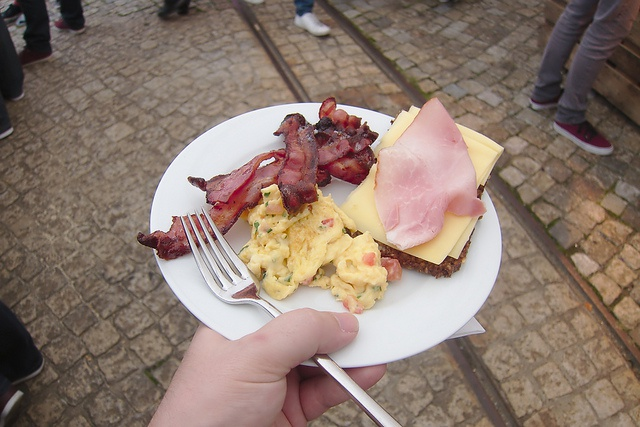Describe the objects in this image and their specific colors. I can see people in gray, pink, darkgray, and brown tones, sandwich in gray, lightpink, tan, lightgray, and maroon tones, people in gray and black tones, fork in gray, lightgray, darkgray, and tan tones, and people in gray, black, and purple tones in this image. 